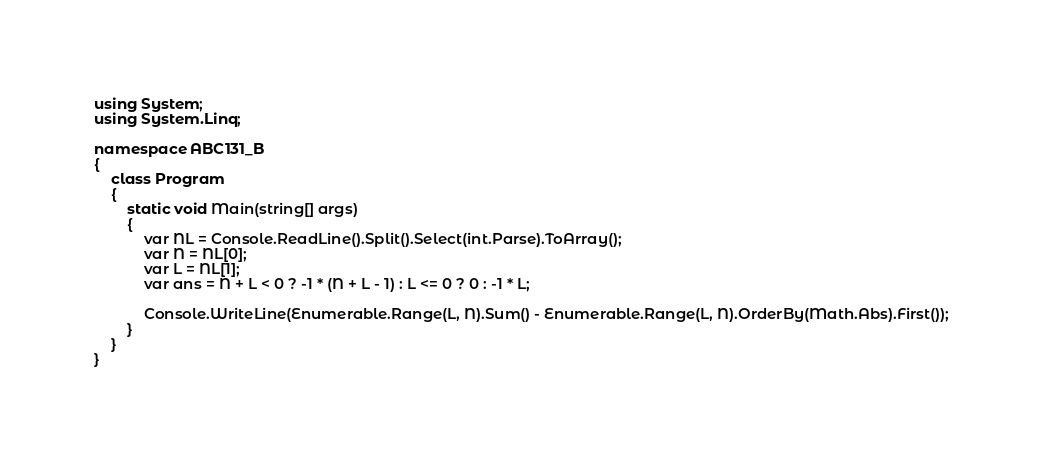<code> <loc_0><loc_0><loc_500><loc_500><_C#_>using System;
using System.Linq;

namespace ABC131_B
{
    class Program
    {
        static void Main(string[] args)
        {
            var NL = Console.ReadLine().Split().Select(int.Parse).ToArray();
            var N = NL[0];
            var L = NL[1];
            var ans = N + L < 0 ? -1 * (N + L - 1) : L <= 0 ? 0 : -1 * L;

            Console.WriteLine(Enumerable.Range(L, N).Sum() - Enumerable.Range(L, N).OrderBy(Math.Abs).First());
        }
    }
}
</code> 